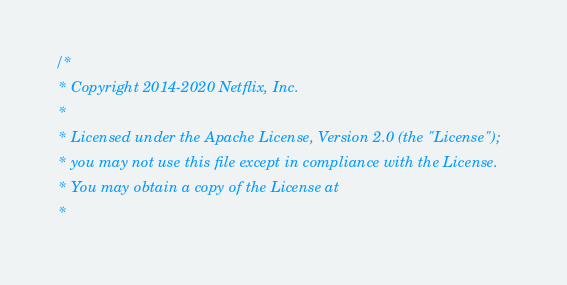Convert code to text. <code><loc_0><loc_0><loc_500><loc_500><_Scala_>/*
 * Copyright 2014-2020 Netflix, Inc.
 *
 * Licensed under the Apache License, Version 2.0 (the "License");
 * you may not use this file except in compliance with the License.
 * You may obtain a copy of the License at
 *</code> 